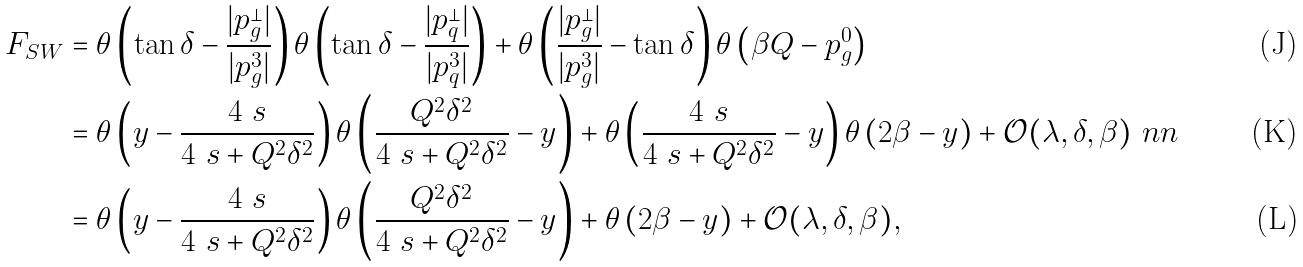Convert formula to latex. <formula><loc_0><loc_0><loc_500><loc_500>F _ { S W } & = \theta \left ( \tan \delta - \frac { | p ^ { \perp } _ { g } | } { | p ^ { 3 } _ { g } | } \right ) \theta \left ( \tan \delta - \frac { | p ^ { \perp } _ { q } | } { | p ^ { 3 } _ { q } | } \right ) + \theta \left ( \frac { | p ^ { \perp } _ { g } | } { | p ^ { 3 } _ { g } | } - \tan \delta \right ) \theta \left ( \beta Q - p ^ { 0 } _ { g } \right ) \\ & = \theta \left ( y - \frac { 4 \ s } { 4 \ s + Q ^ { 2 } \delta ^ { 2 } } \right ) \theta \left ( \frac { Q ^ { 2 } \delta ^ { 2 } } { 4 \ s + Q ^ { 2 } \delta ^ { 2 } } - y \right ) + \theta \left ( \frac { 4 \ s } { 4 \ s + Q ^ { 2 } \delta ^ { 2 } } - y \right ) \theta \left ( 2 \beta - y \right ) + \mathcal { O } ( \lambda , \delta , \beta ) \ n n \\ & = \theta \left ( y - \frac { 4 \ s } { 4 \ s + Q ^ { 2 } \delta ^ { 2 } } \right ) \theta \left ( \frac { Q ^ { 2 } \delta ^ { 2 } } { 4 \ s + Q ^ { 2 } \delta ^ { 2 } } - y \right ) + \theta \left ( 2 \beta - y \right ) + \mathcal { O } ( \lambda , \delta , \beta ) ,</formula> 